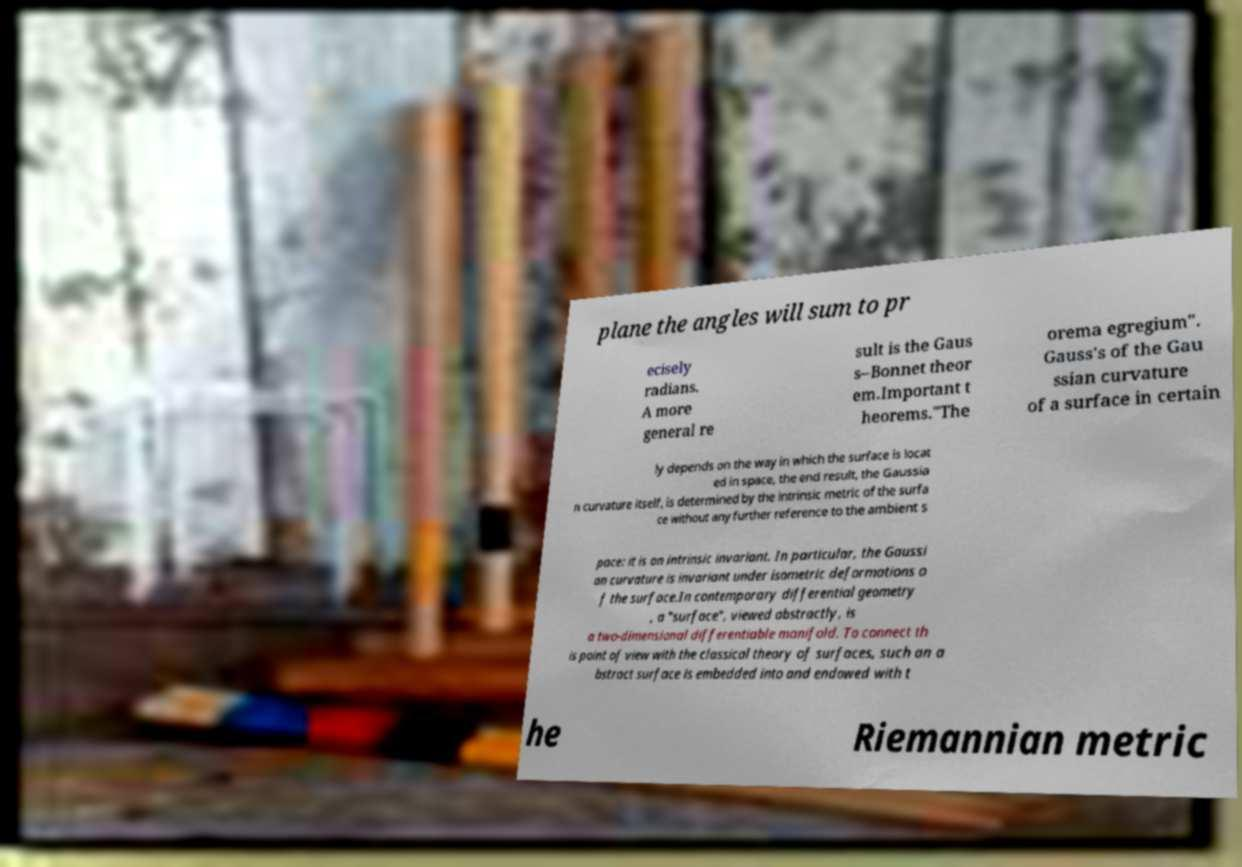There's text embedded in this image that I need extracted. Can you transcribe it verbatim? plane the angles will sum to pr ecisely radians. A more general re sult is the Gaus s–Bonnet theor em.Important t heorems."The orema egregium". Gauss's of the Gau ssian curvature of a surface in certain ly depends on the way in which the surface is locat ed in space, the end result, the Gaussia n curvature itself, is determined by the intrinsic metric of the surfa ce without any further reference to the ambient s pace: it is an intrinsic invariant. In particular, the Gaussi an curvature is invariant under isometric deformations o f the surface.In contemporary differential geometry , a "surface", viewed abstractly, is a two-dimensional differentiable manifold. To connect th is point of view with the classical theory of surfaces, such an a bstract surface is embedded into and endowed with t he Riemannian metric 